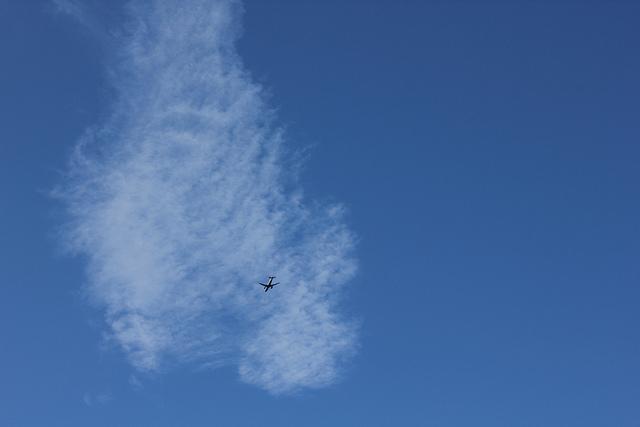How many jets are flying?
Give a very brief answer. 1. How many airplanes are flying in the sky?
Give a very brief answer. 1. How many shades of blue are in this picture?
Give a very brief answer. 1. 